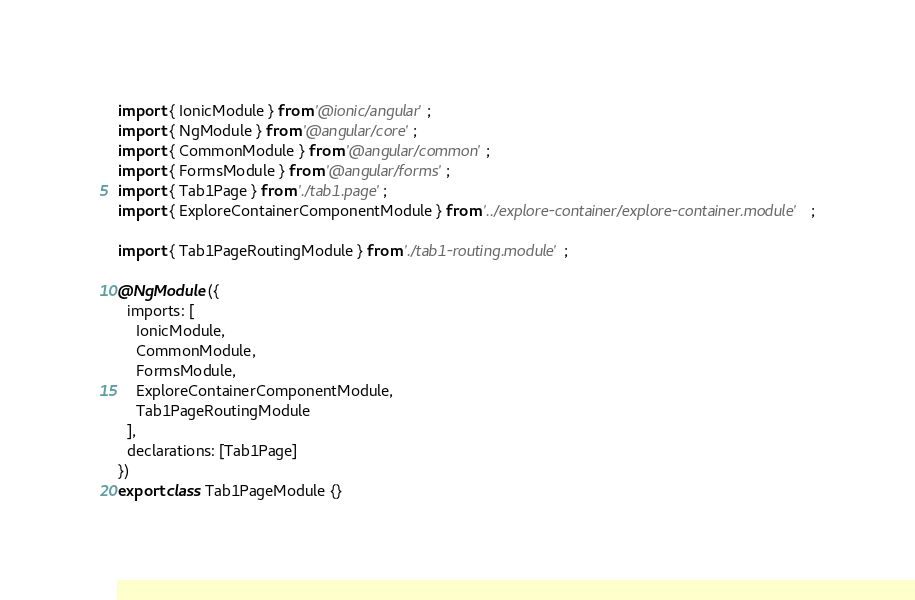<code> <loc_0><loc_0><loc_500><loc_500><_TypeScript_>import { IonicModule } from '@ionic/angular';
import { NgModule } from '@angular/core';
import { CommonModule } from '@angular/common';
import { FormsModule } from '@angular/forms';
import { Tab1Page } from './tab1.page';
import { ExploreContainerComponentModule } from '../explore-container/explore-container.module';

import { Tab1PageRoutingModule } from './tab1-routing.module';

@NgModule({
  imports: [
    IonicModule,
    CommonModule,
    FormsModule,
    ExploreContainerComponentModule,
    Tab1PageRoutingModule
  ],
  declarations: [Tab1Page]
})
export class Tab1PageModule {}

</code> 